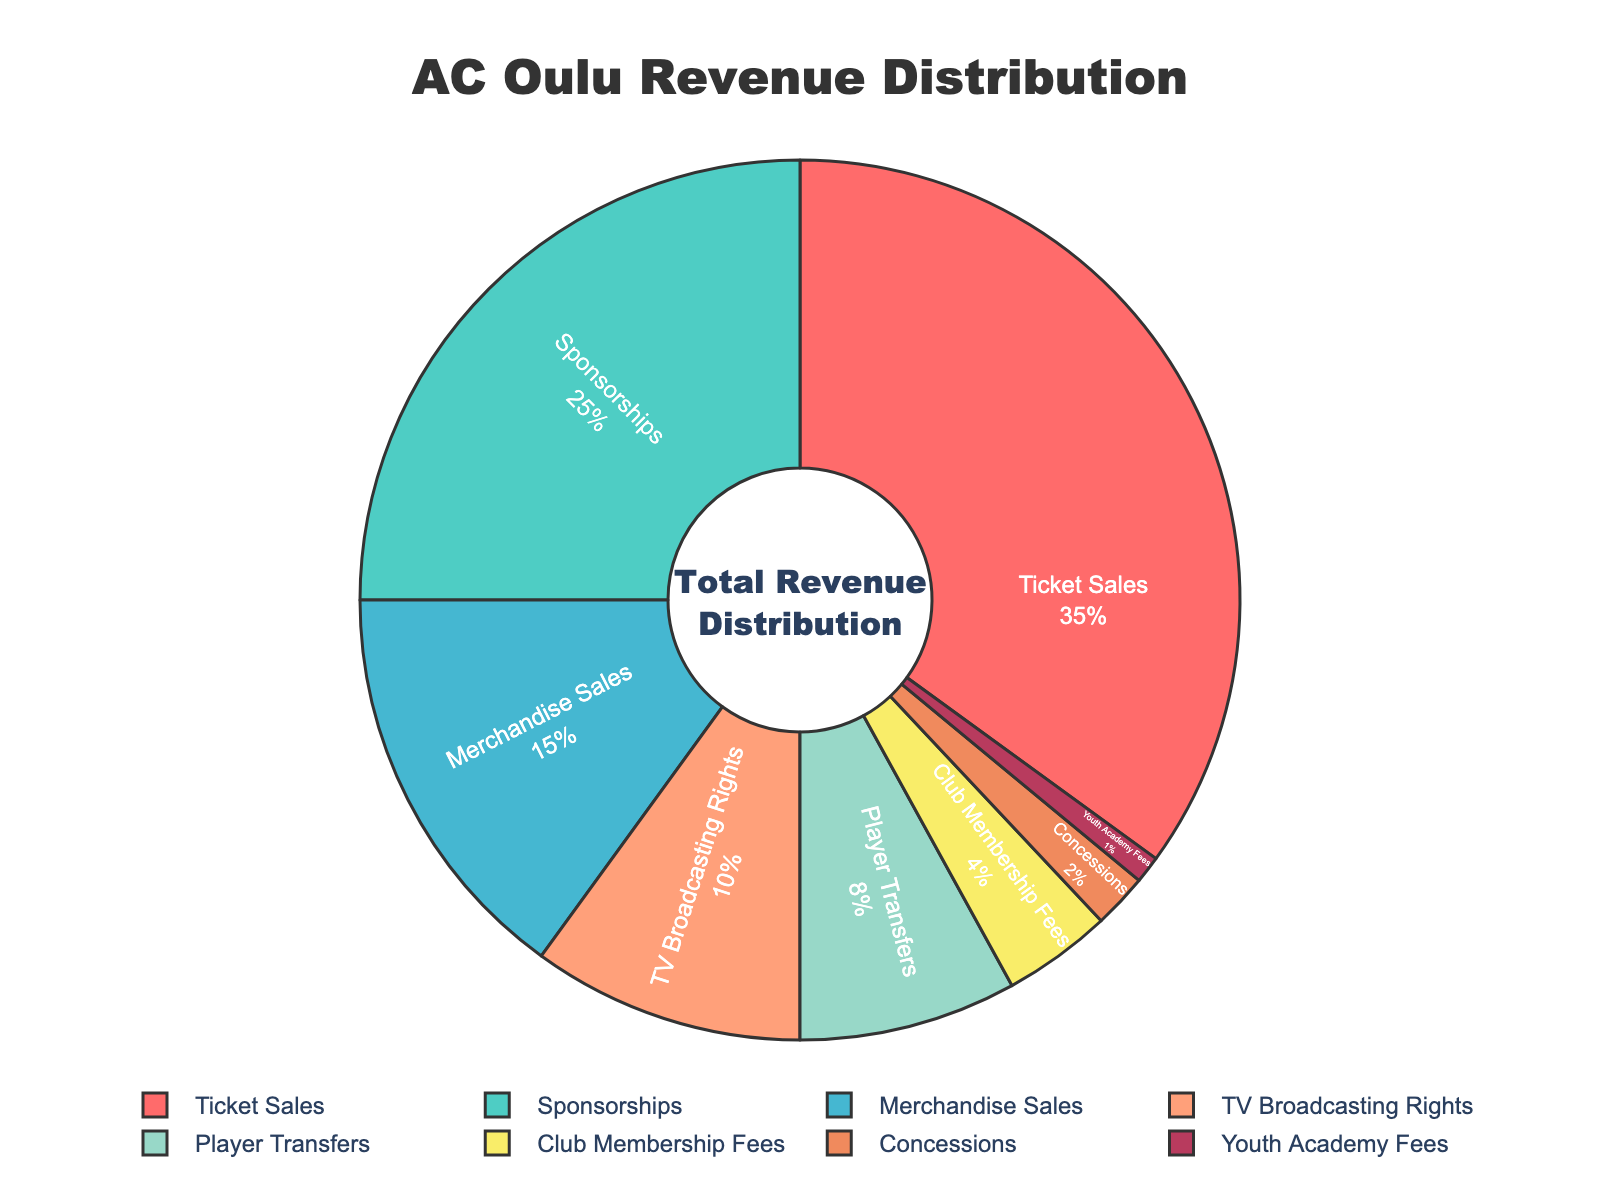What is the largest source of revenue for AC Oulu? The pie chart shows that ticket sales occupy the largest portion of the chart. The label for ticket sales indicates 35%.
Answer: Ticket sales What percentage of AC Oulu's revenue comes from sponsorships and merchandise sales combined? Identify the percentages for sponsorships (25%) and merchandise sales (15%) from the chart, then add them together: 25% + 15% = 40%.
Answer: 40% Which revenue source contributes the least to AC Oulu's revenue? The pie chart segment for Youth Academy Fees shows the smallest percentage at 1%.
Answer: Youth Academy Fees How much more revenue percentage does ticket sales contribute compared to TV broadcasting rights? Identify the percentages for ticket sales (35%) and TV broadcasting rights (10%), then subtract the latter from the former: 35% - 10% = 25%.
Answer: 25% What is the combined revenue percentage from sources that contribute less than 10% each? Identify the percentages for concessions (2%), club membership fees (4%), and youth academy fees (1%). Add them together: 2% + 4% + 1% = 7%.
Answer: 7% What proportion of revenue does player transfers and TV broadcasting rights together represent? Identify the percentages for player transfers (8%) and TV broadcasting rights (10%), then add them together: 8% + 10% = 18%.
Answer: 18% Visualizing the colors representing revenue distribution, what color is used for the segment representing merchandise sales? Observe the color directly on the pie chart for the merchandise sales segment. It is identified by '#FFA07A', which corresponds to peach or light orange.
Answer: Peach/light orange Is there any revenue source that has exactly a quarter portion (25%) of the total revenue? Cross-check all the segments and their labels to find any that exactly match 25%. The sponsorship segment is labeled 25%.
Answer: Sponsorships Considering the visual distribution, how many sections of the chart represent revenue sources less than 10%? Identify and count the number of segments less than 10%: TV broadcasting rights (10% is not less than), player transfers (8%), club membership fees (4%), concessions (2%), youth academy fees (1%). Total count is 4.
Answer: 4 Which revenue source has a larger share, player transfers or club membership fees? By how much? Identify the percentages for player transfers (8%) and club membership fees (4%). Subtract club membership fees from player transfers: 8% - 4% = 4%.
Answer: Player transfers by 4% 